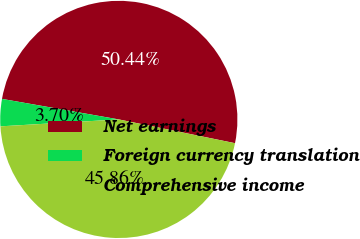<chart> <loc_0><loc_0><loc_500><loc_500><pie_chart><fcel>Net earnings<fcel>Foreign currency translation<fcel>Comprehensive income<nl><fcel>50.44%<fcel>3.7%<fcel>45.86%<nl></chart> 